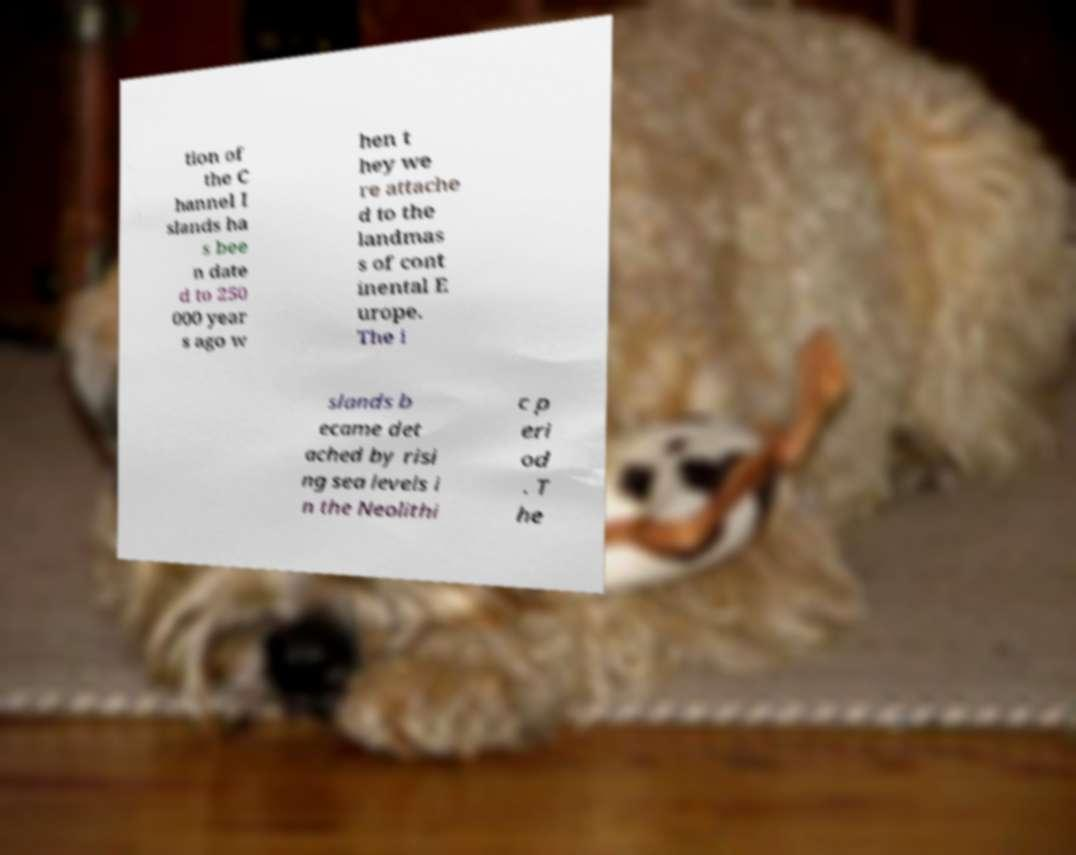Can you read and provide the text displayed in the image?This photo seems to have some interesting text. Can you extract and type it out for me? tion of the C hannel I slands ha s bee n date d to 250 000 year s ago w hen t hey we re attache d to the landmas s of cont inental E urope. The i slands b ecame det ached by risi ng sea levels i n the Neolithi c p eri od . T he 